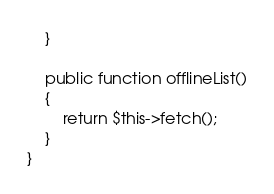Convert code to text. <code><loc_0><loc_0><loc_500><loc_500><_PHP_>    }

    public function offlineList()
    {
        return $this->fetch();
    }
}</code> 